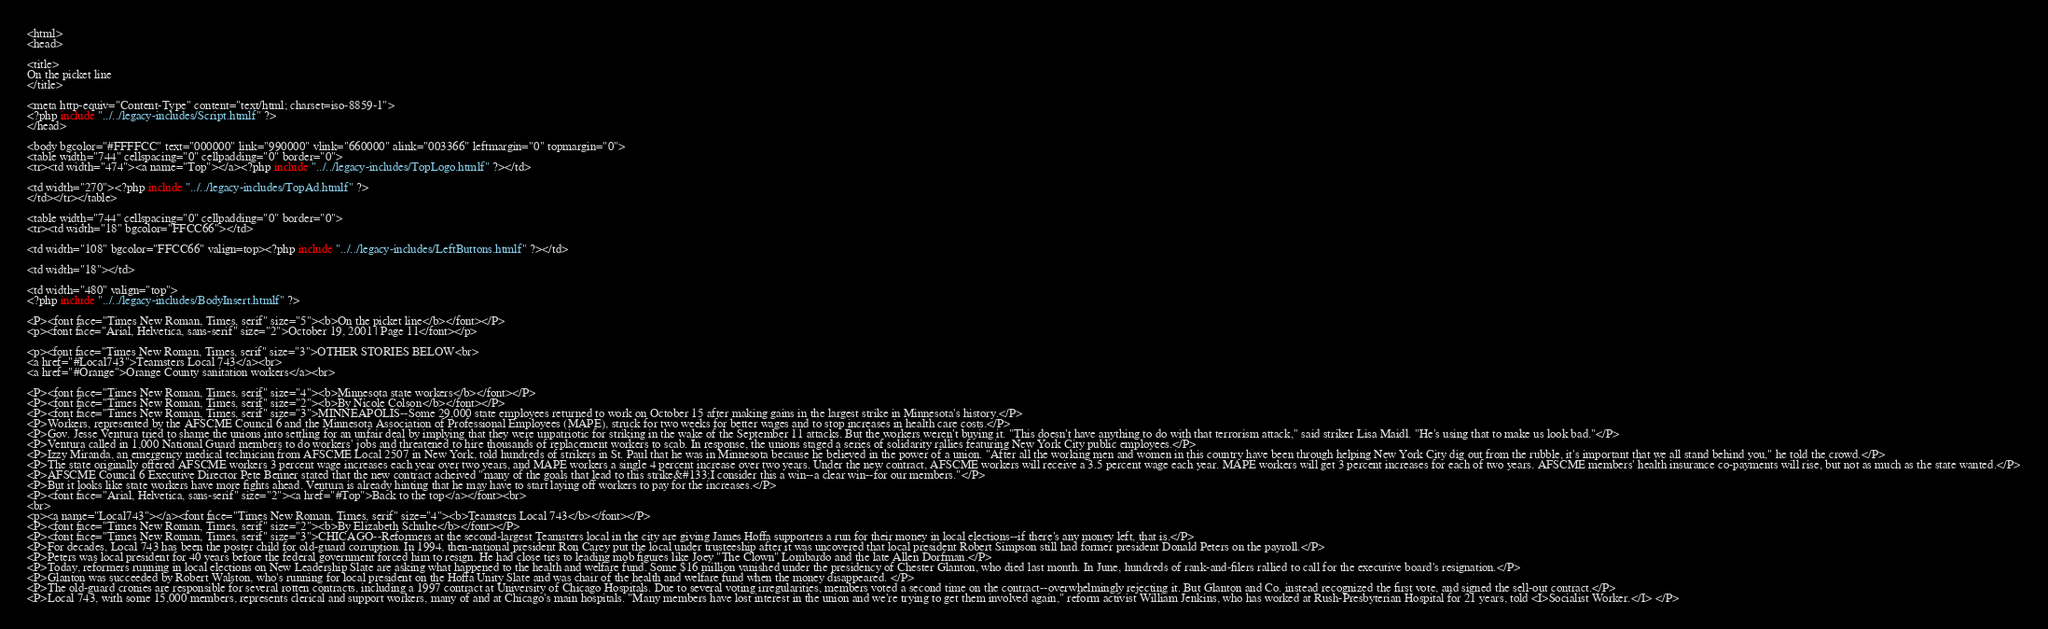<code> <loc_0><loc_0><loc_500><loc_500><_PHP_><html>
<head>

<title>
On the picket line
</title>

<meta http-equiv="Content-Type" content="text/html; charset=iso-8859-1">
<?php include "../../legacy-includes/Script.htmlf" ?>
</head>

<body bgcolor="#FFFFCC" text="000000" link="990000" vlink="660000" alink="003366" leftmargin="0" topmargin="0">
<table width="744" cellspacing="0" cellpadding="0" border="0">
<tr><td width="474"><a name="Top"></a><?php include "../../legacy-includes/TopLogo.htmlf" ?></td>

<td width="270"><?php include "../../legacy-includes/TopAd.htmlf" ?>
</td></tr></table>

<table width="744" cellspacing="0" cellpadding="0" border="0">
<tr><td width="18" bgcolor="FFCC66"></td>

<td width="108" bgcolor="FFCC66" valign=top><?php include "../../legacy-includes/LeftButtons.htmlf" ?></td>

<td width="18"></td>

<td width="480" valign="top">
<?php include "../../legacy-includes/BodyInsert.htmlf" ?>

<P><font face="Times New Roman, Times, serif" size="5"><b>On the picket line</b></font></P>
<p><font face="Arial, Helvetica, sans-serif" size="2">October 19, 2001 | Page 11</font></p>

<p><font face="Times New Roman, Times, serif" size="3">OTHER STORIES BELOW<br>
<a href="#Local743">Teamsters Local 743</a><br>
<a href="#Orange">Orange County sanitation workers</a><br>

<P><font face="Times New Roman, Times, serif" size="4"><b>Minnesota state workers</b></font></P>
<P><font face="Times New Roman, Times, serif" size="2"><b>By Nicole Colson</b></font></P>
<P><font face="Times New Roman, Times, serif" size="3">MINNEAPOLIS--Some 29,000 state employees returned to work on October 15 after making gains in the largest strike in Minnesota's history.</P>
<P>Workers, represented by the AFSCME Council 6 and the Minnesota Association of Professional Employees (MAPE), struck for two weeks for better wages and to stop increases in health care costs.</P>
<P>Gov. Jesse Ventura tried to shame the unions into settling for an unfair deal by implying that they were unpatriotic for striking in the wake of the September 11 attacks. But the workers weren't buying it. "This doesn't have anything to do with that terrorism attack," said striker Lisa Maidl. "He's using that to make us look bad."</P>
<P>Ventura called in 1,000 National Guard members to do workers' jobs and threatened to hire thousands of replacement workers to scab. In response, the unions staged a series of solidarity rallies featuring New York City public employees.</P>
<P>Izzy Miranda, an emergency medical technician from AFSCME Local 2507 in New York, told hundreds of strikers in St. Paul that he was in Minnesota because he believed in the power of a union. "After all the working men and women in this country have been through helping New York City dig out from the rubble, it's important that we all stand behind you," he told the crowd.</P>
<P>The state originally offered AFSCME workers 3 percent wage increases each year over two years, and MAPE workers a single 4 percent increase over two years. Under the new contract, AFSCME workers will receive a 3.5 percent wage each year. MAPE workers will get 3 percent increases for each of two years. AFSCME members' health insurance co-payments will rise, but not as much as the state wanted.</P>
<P>AFSCME Council 6 Executive Director Pete Benner stated that the new contract acheived "many of the goals that lead to this strike&#133;I consider this a win--a clear win--for our members."</P>
<P>But it looks like state workers have more fights ahead. Ventura is already hinting that he may have to start laying off workers to pay for the increases.</P>
<P><font face="Arial, Helvetica, sans-serif" size="2"><a href="#Top">Back to the top</a></font><br>
<br>
<p><a name="Local743"></a><font face="Times New Roman, Times, serif" size="4"><b>Teamsters Local 743</b></font></P>
<P><font face="Times New Roman, Times, serif" size="2"><b>By Elizabeth Schulte</b></font></P>
<P><font face="Times New Roman, Times, serif" size="3">CHICAGO--Reformers at the second-largest Teamsters local in the city are giving James Hoffa supporters a run for their money in local elections--if there's any money left, that is.</P>
<P>For decades, Local 743 has been the poster child for old-guard corruption. In 1994, then-national president Ron Carey put the local under trusteeship after it was uncovered that local president Robert Simpson still had former president Donald Peters on the payroll.</P>
<P>Peters was local president for 40 years before the federal government forced him to resign. He had close ties to leading mob figures like Joey "The Clown" Lombardo and the late Allen Dorfman.</P>
<P>Today, reformers running in local elections on New Leadership Slate are asking what happened to the health and welfare fund. Some $16 million vanished under the presidency of Chester Glanton, who died last month. In June, hundreds of rank-and-filers rallied to call for the executive board's resignation.</P>
<P>Glanton was succeeded by Robert Walston, who's running for local president on the Hoffa Unity Slate and was chair of the health and welfare fund when the money disappeared. </P>
<P>The old-guard cronies are responsible for several rotten contracts, including a 1997 contract at University of Chicago Hospitals. Due to several voting irregularities, members voted a second time on the contract--overwhelmingly rejecting it. But Glanton and Co. instead recognized the first vote, and signed the sell-out contract.</P>
<P>Local 743, with some 15,000 members, represents clerical and support workers, many of and at Chicago's main hospitals. "Many members have lost interest in the union and we're trying to get them involved again," reform activist William Jenkins, who has worked at Rush-Presbyterian Hospital for 21 years, told <I>Socialist Worker.</I> </P></code> 